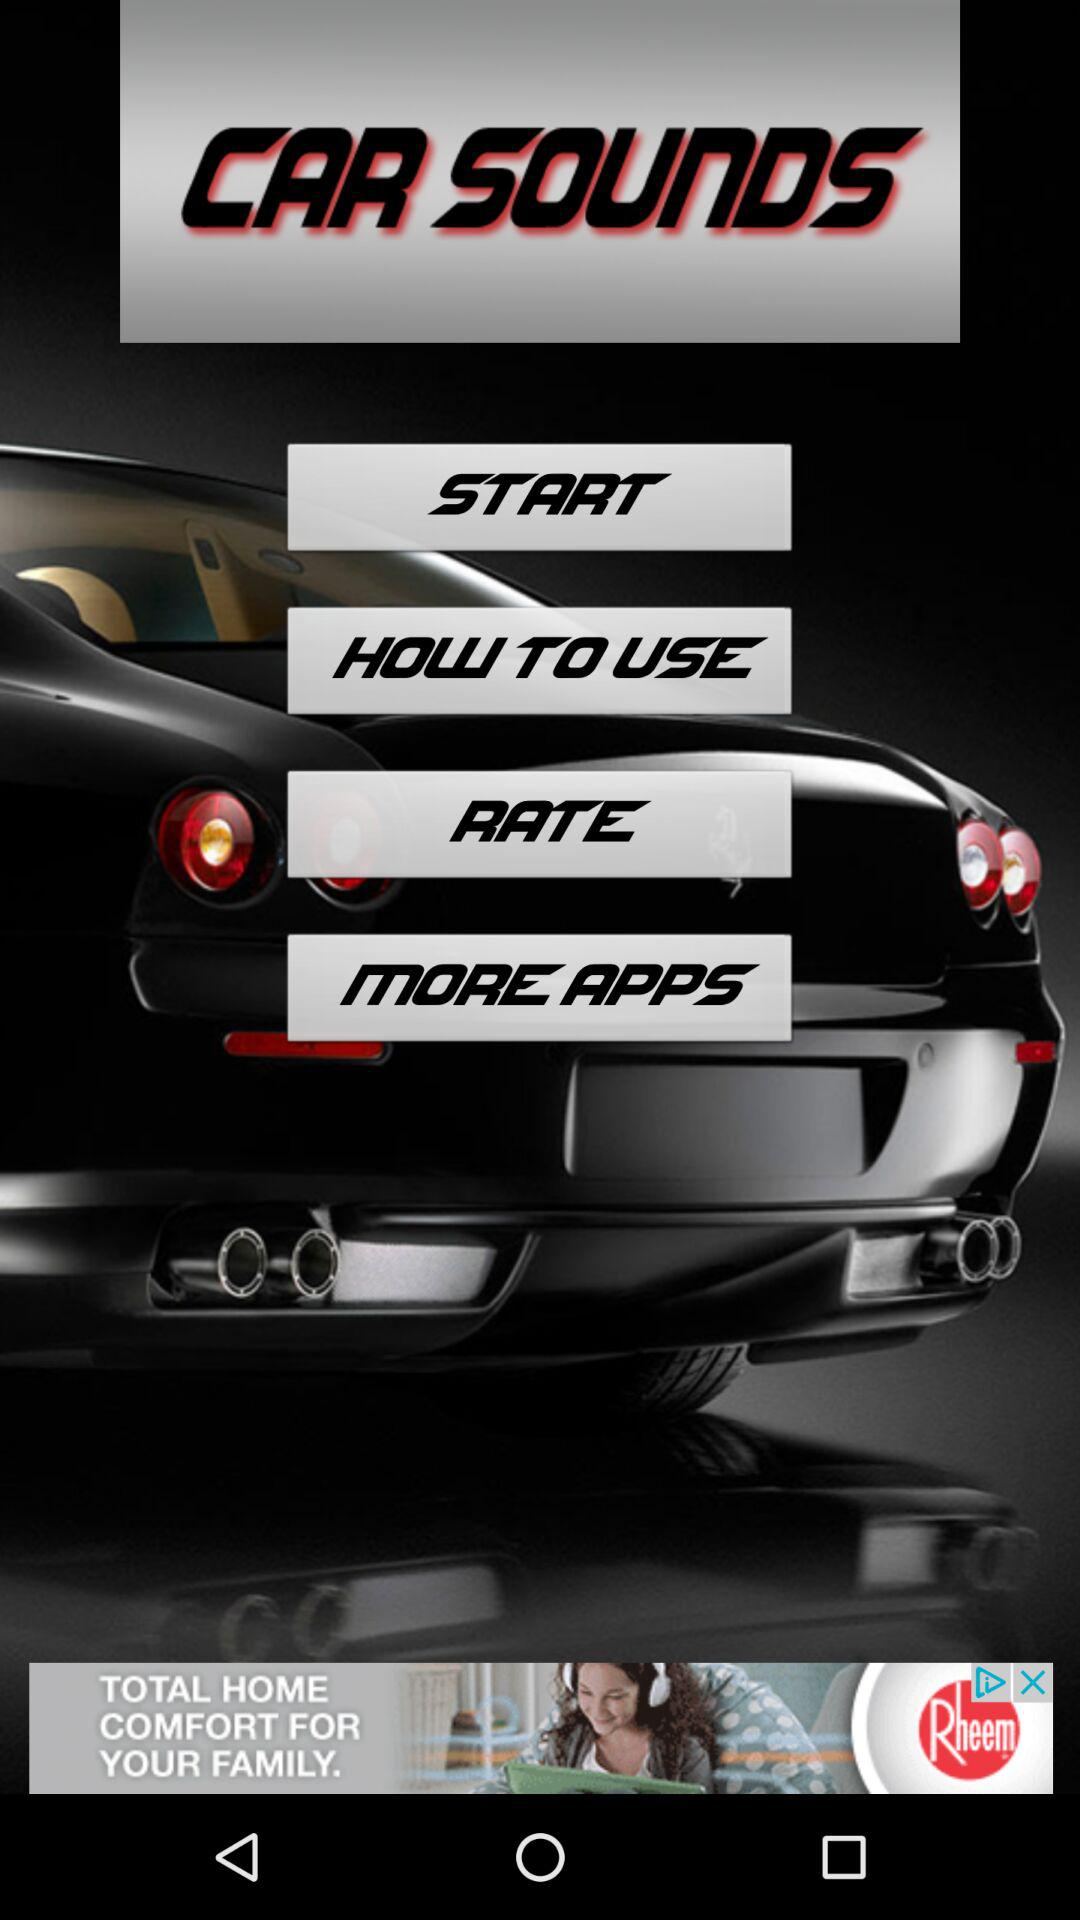What is the application name? The application name is "CAR SOUNDS". 